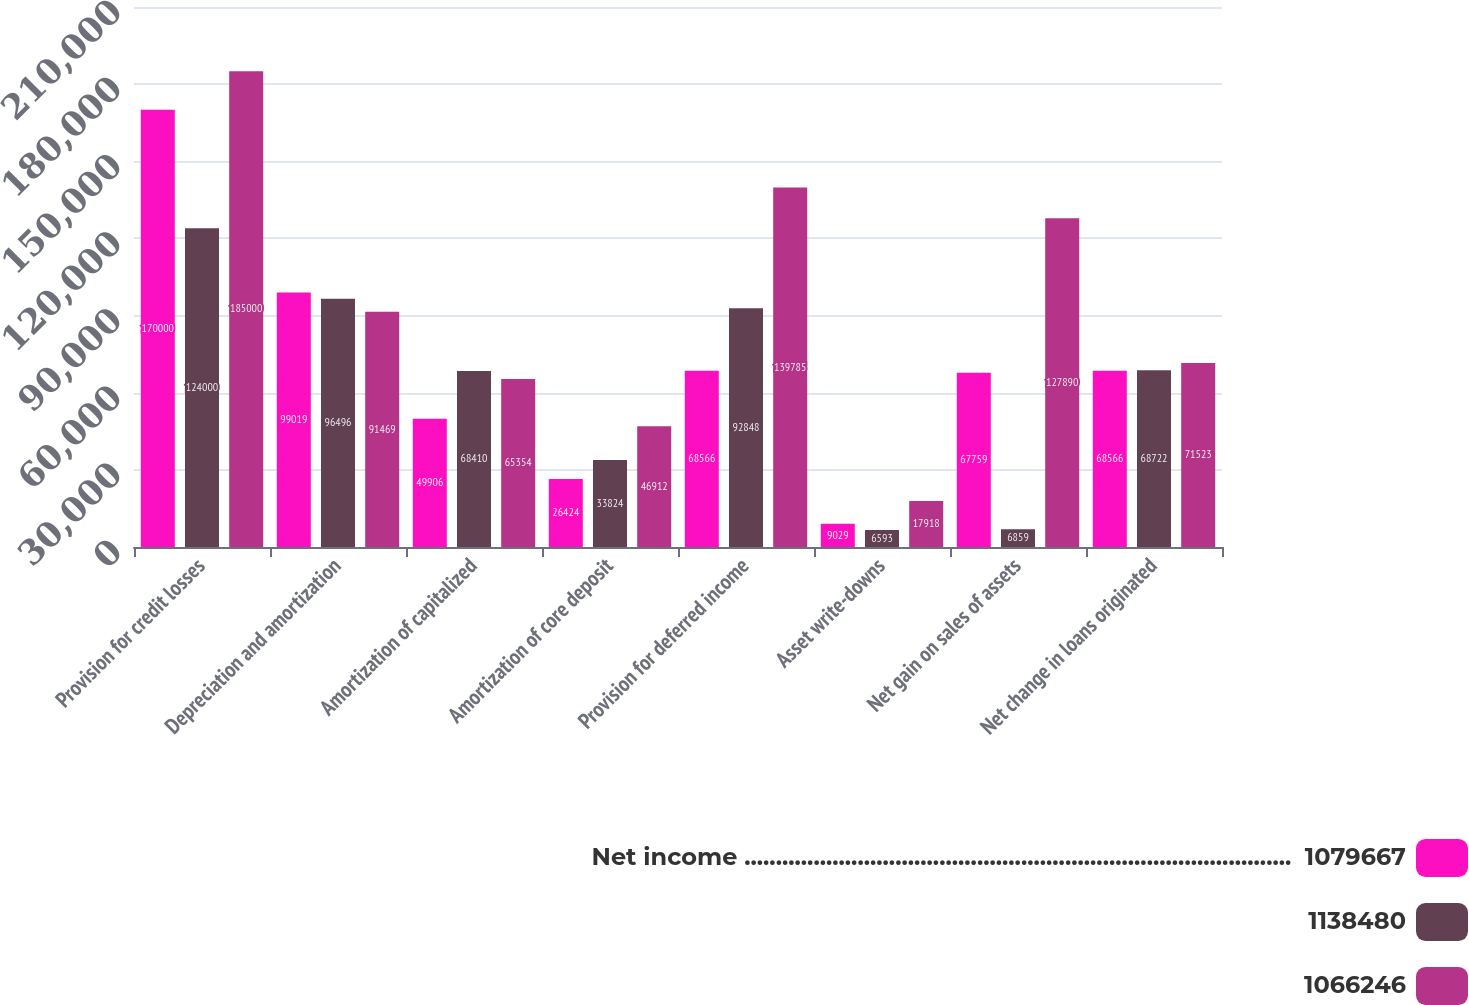Convert chart. <chart><loc_0><loc_0><loc_500><loc_500><stacked_bar_chart><ecel><fcel>Provision for credit losses<fcel>Depreciation and amortization<fcel>Amortization of capitalized<fcel>Amortization of core deposit<fcel>Provision for deferred income<fcel>Asset write-downs<fcel>Net gain on sales of assets<fcel>Net change in loans originated<nl><fcel>Net income .......................................................................................  1079667<fcel>170000<fcel>99019<fcel>49906<fcel>26424<fcel>68566<fcel>9029<fcel>67759<fcel>68566<nl><fcel>1138480<fcel>124000<fcel>96496<fcel>68410<fcel>33824<fcel>92848<fcel>6593<fcel>6859<fcel>68722<nl><fcel>1066246<fcel>185000<fcel>91469<fcel>65354<fcel>46912<fcel>139785<fcel>17918<fcel>127890<fcel>71523<nl></chart> 